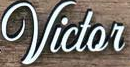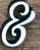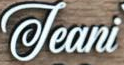Transcribe the words shown in these images in order, separated by a semicolon. Victor; &; Jeani 